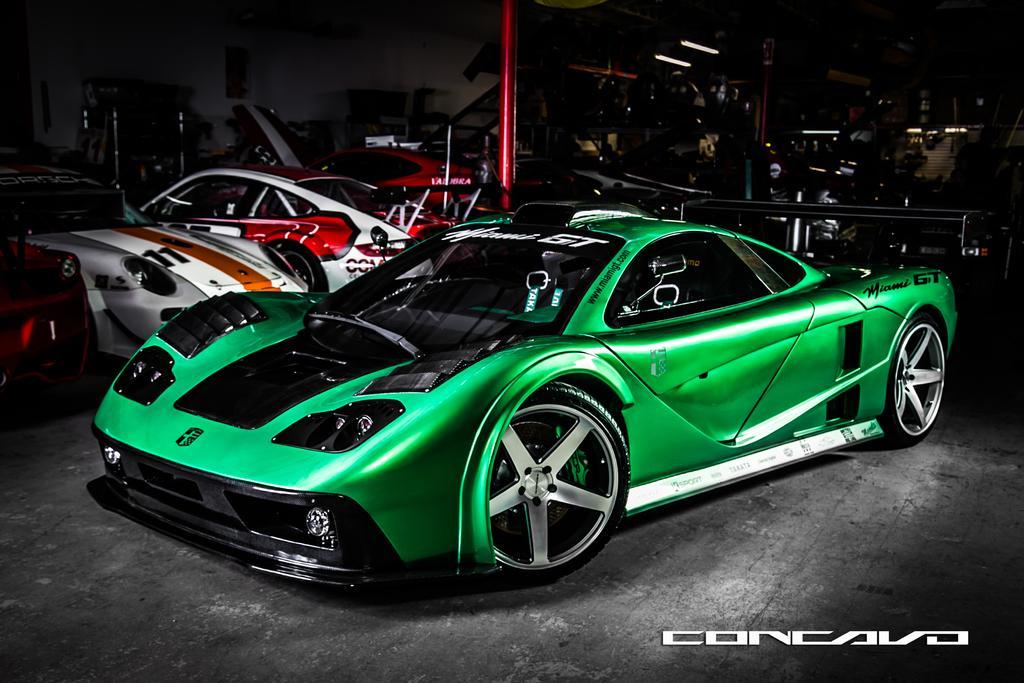Could you give a brief overview of what you see in this image? In this picture I can observe green color car on the floor. In the background I can observe some cars parked on the floor. I can observe red color pole in the middle of the picture. 